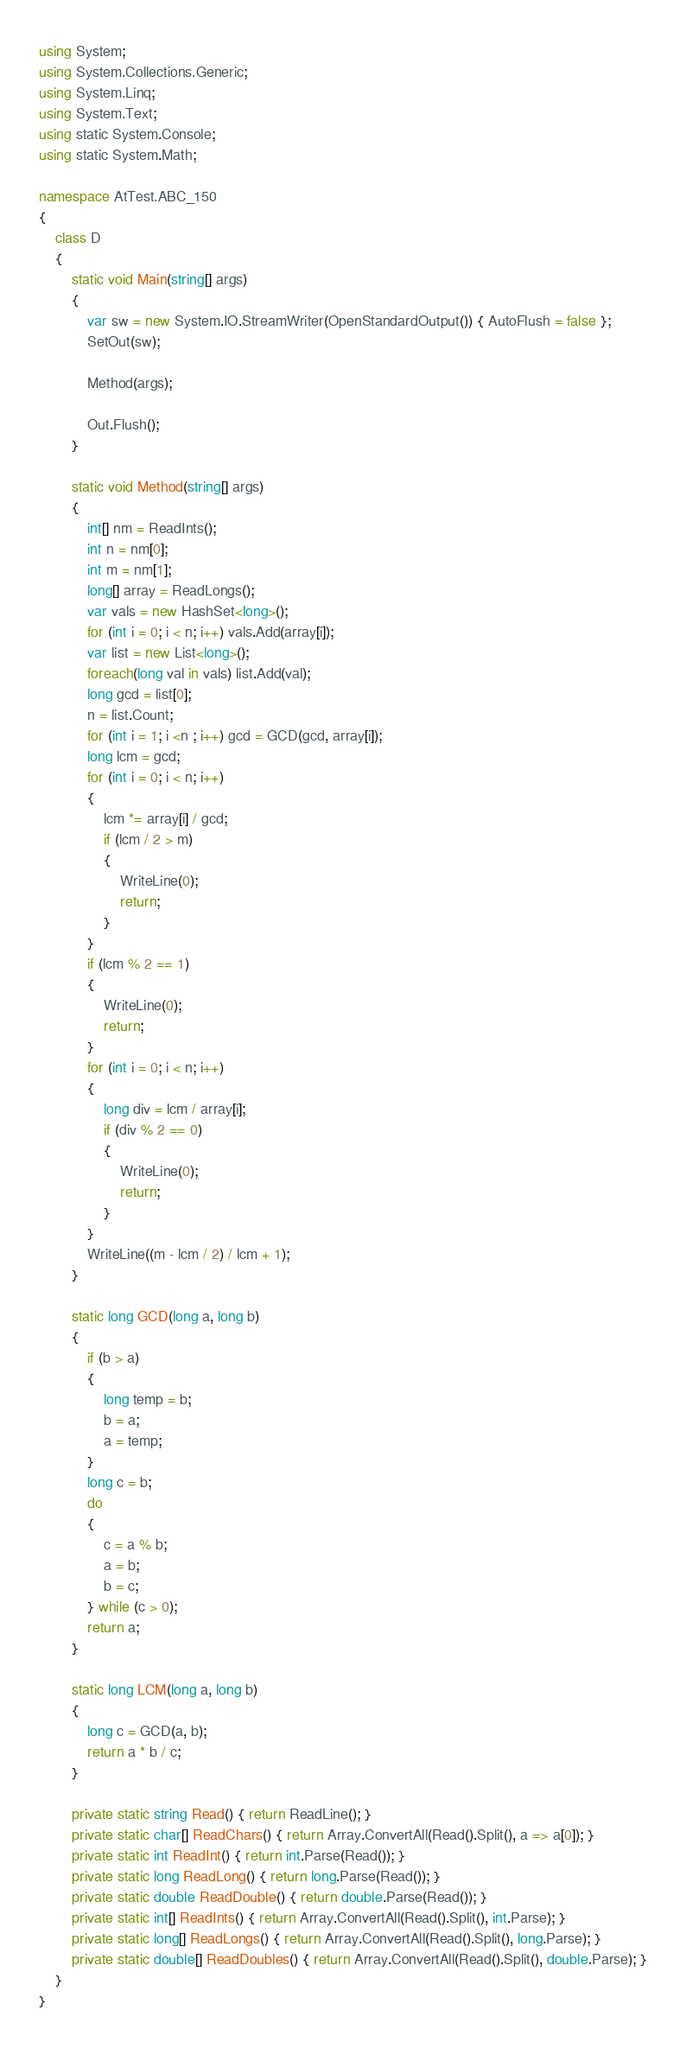<code> <loc_0><loc_0><loc_500><loc_500><_C#_>using System;
using System.Collections.Generic;
using System.Linq;
using System.Text;
using static System.Console;
using static System.Math;

namespace AtTest.ABC_150
{
    class D
    {
        static void Main(string[] args)
        {
            var sw = new System.IO.StreamWriter(OpenStandardOutput()) { AutoFlush = false };
            SetOut(sw);

            Method(args);

            Out.Flush();
        }

        static void Method(string[] args)
        {
            int[] nm = ReadInts();
            int n = nm[0];
            int m = nm[1];
            long[] array = ReadLongs();
            var vals = new HashSet<long>();
            for (int i = 0; i < n; i++) vals.Add(array[i]);
            var list = new List<long>();
            foreach(long val in vals) list.Add(val);
            long gcd = list[0];
            n = list.Count;
            for (int i = 1; i <n ; i++) gcd = GCD(gcd, array[i]);
            long lcm = gcd;
            for (int i = 0; i < n; i++)
            {
                lcm *= array[i] / gcd;
                if (lcm / 2 > m)
                {
                    WriteLine(0);
                    return;
                }
            }
            if (lcm % 2 == 1)
            {
                WriteLine(0);
                return;
            }
            for (int i = 0; i < n; i++)
            {
                long div = lcm / array[i];
                if (div % 2 == 0)
                {
                    WriteLine(0);
                    return;
                }
            }
            WriteLine((m - lcm / 2) / lcm + 1);
        }

        static long GCD(long a, long b)
        {
            if (b > a)
            {
                long temp = b;
                b = a;
                a = temp;
            }
            long c = b;
            do
            {
                c = a % b;
                a = b;
                b = c;
            } while (c > 0);
            return a;
        }

        static long LCM(long a, long b)
        {
            long c = GCD(a, b);
            return a * b / c;
        }

        private static string Read() { return ReadLine(); }
        private static char[] ReadChars() { return Array.ConvertAll(Read().Split(), a => a[0]); }
        private static int ReadInt() { return int.Parse(Read()); }
        private static long ReadLong() { return long.Parse(Read()); }
        private static double ReadDouble() { return double.Parse(Read()); }
        private static int[] ReadInts() { return Array.ConvertAll(Read().Split(), int.Parse); }
        private static long[] ReadLongs() { return Array.ConvertAll(Read().Split(), long.Parse); }
        private static double[] ReadDoubles() { return Array.ConvertAll(Read().Split(), double.Parse); }
    }
}
</code> 